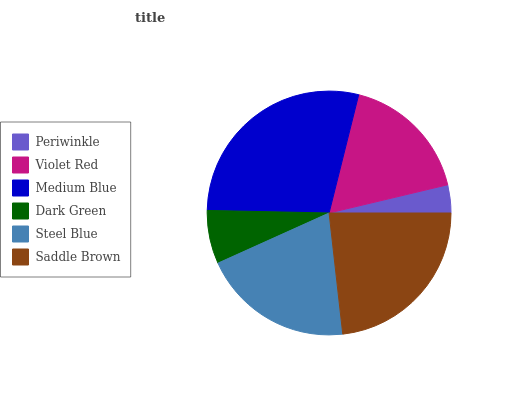Is Periwinkle the minimum?
Answer yes or no. Yes. Is Medium Blue the maximum?
Answer yes or no. Yes. Is Violet Red the minimum?
Answer yes or no. No. Is Violet Red the maximum?
Answer yes or no. No. Is Violet Red greater than Periwinkle?
Answer yes or no. Yes. Is Periwinkle less than Violet Red?
Answer yes or no. Yes. Is Periwinkle greater than Violet Red?
Answer yes or no. No. Is Violet Red less than Periwinkle?
Answer yes or no. No. Is Steel Blue the high median?
Answer yes or no. Yes. Is Violet Red the low median?
Answer yes or no. Yes. Is Periwinkle the high median?
Answer yes or no. No. Is Medium Blue the low median?
Answer yes or no. No. 